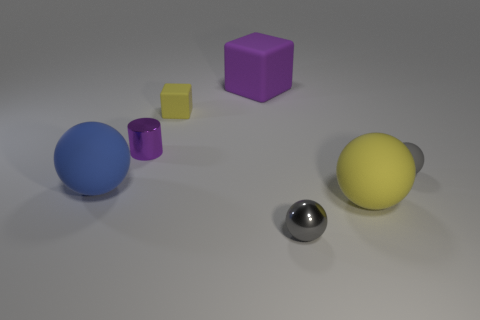Subtract all cylinders. How many objects are left? 6 Add 7 tiny purple metallic objects. How many tiny purple metallic objects are left? 8 Add 1 yellow balls. How many yellow balls exist? 2 Subtract 0 red cylinders. How many objects are left? 7 Subtract all small gray cubes. Subtract all tiny gray matte objects. How many objects are left? 6 